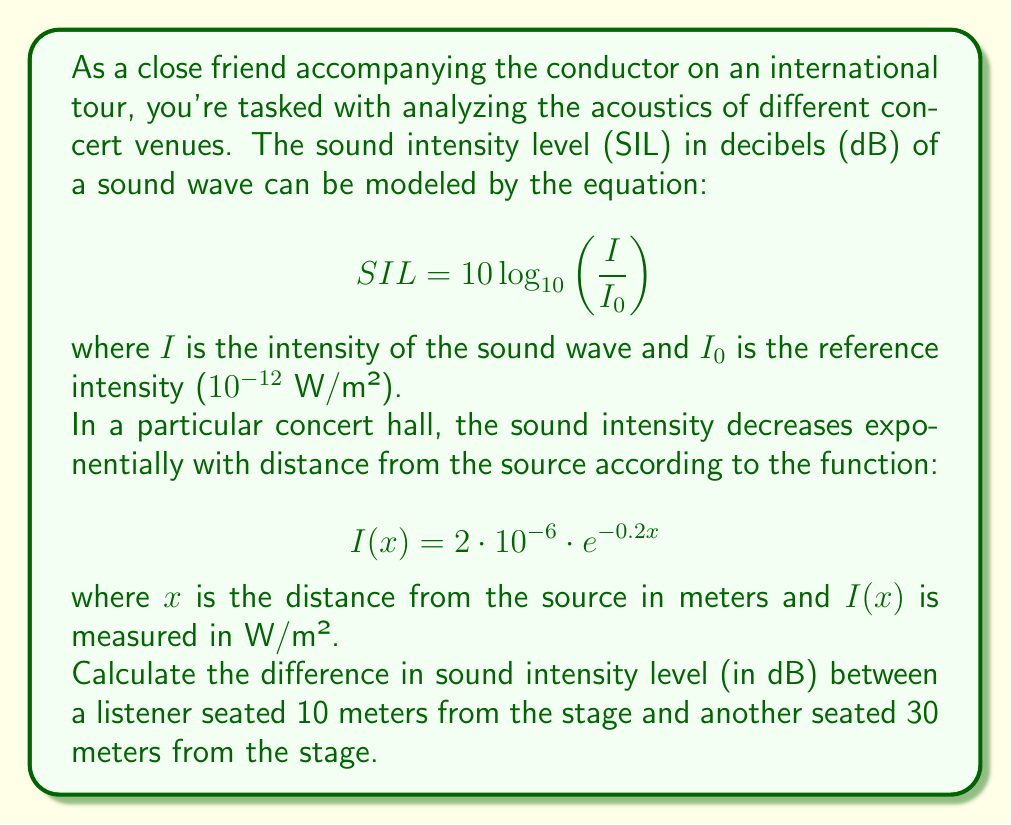Provide a solution to this math problem. To solve this problem, we need to follow these steps:

1) First, let's calculate the sound intensity at 10 meters and 30 meters using the given function:

   At 10 meters: $I(10) = 2 \cdot 10^{-6} \cdot e^{-0.2(10)} = 2 \cdot 10^{-6} \cdot e^{-2} \approx 2.706 \cdot 10^{-7}$ W/m²
   
   At 30 meters: $I(30) = 2 \cdot 10^{-6} \cdot e^{-0.2(30)} = 2 \cdot 10^{-6} \cdot e^{-6} \approx 4.979 \cdot 10^{-9}$ W/m²

2) Now, let's calculate the SIL at each position using the SIL equation:

   At 10 meters: 
   $$ SIL_{10} = 10 \log_{10}\left(\frac{2.706 \cdot 10^{-7}}{10^{-12}}\right) \approx 54.32 \text{ dB} $$

   At 30 meters:
   $$ SIL_{30} = 10 \log_{10}\left(\frac{4.979 \cdot 10^{-9}}{10^{-12}}\right) \approx 36.97 \text{ dB} $$

3) The difference in SIL is:

   $$ \Delta SIL = SIL_{10} - SIL_{30} = 54.32 - 36.97 = 17.35 \text{ dB} $$

Therefore, the difference in sound intensity level between a listener at 10 meters and another at 30 meters is approximately 17.35 dB.
Answer: 17.35 dB 